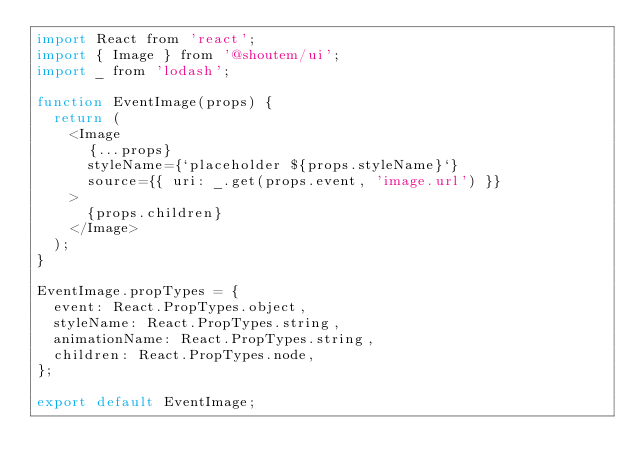<code> <loc_0><loc_0><loc_500><loc_500><_JavaScript_>import React from 'react';
import { Image } from '@shoutem/ui';
import _ from 'lodash';

function EventImage(props) {
  return (
    <Image
      {...props}
      styleName={`placeholder ${props.styleName}`}
      source={{ uri: _.get(props.event, 'image.url') }}
    >
      {props.children}
    </Image>
  );
}

EventImage.propTypes = {
  event: React.PropTypes.object,
  styleName: React.PropTypes.string,
  animationName: React.PropTypes.string,
  children: React.PropTypes.node,
};

export default EventImage;
</code> 